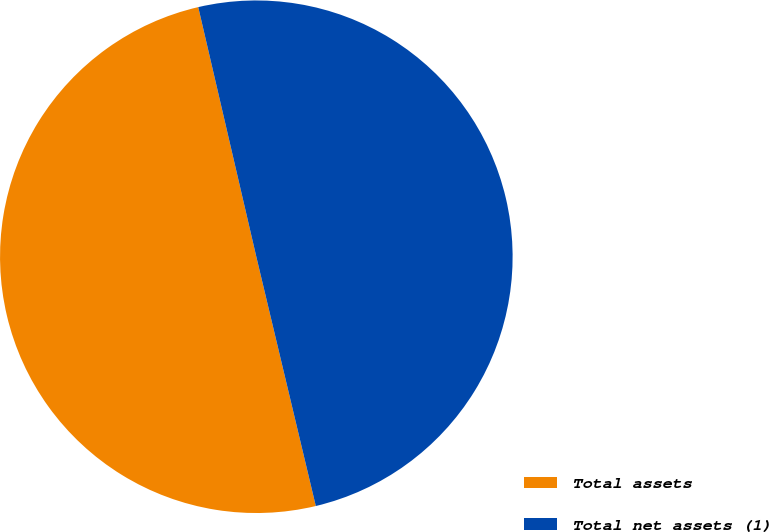<chart> <loc_0><loc_0><loc_500><loc_500><pie_chart><fcel>Total assets<fcel>Total net assets (1)<nl><fcel>50.09%<fcel>49.91%<nl></chart> 